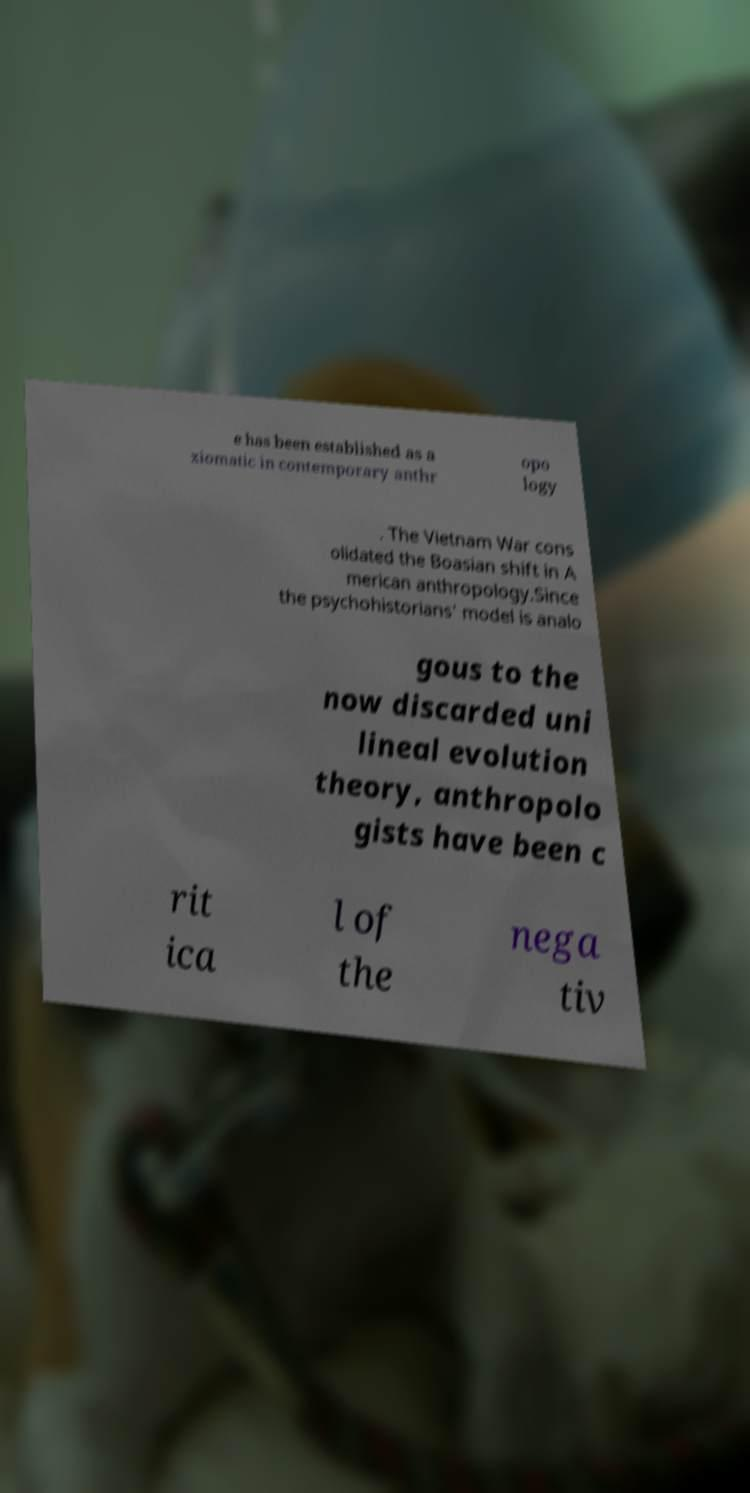Please read and relay the text visible in this image. What does it say? e has been established as a xiomatic in contemporary anthr opo logy . The Vietnam War cons olidated the Boasian shift in A merican anthropology.Since the psychohistorians' model is analo gous to the now discarded uni lineal evolution theory, anthropolo gists have been c rit ica l of the nega tiv 